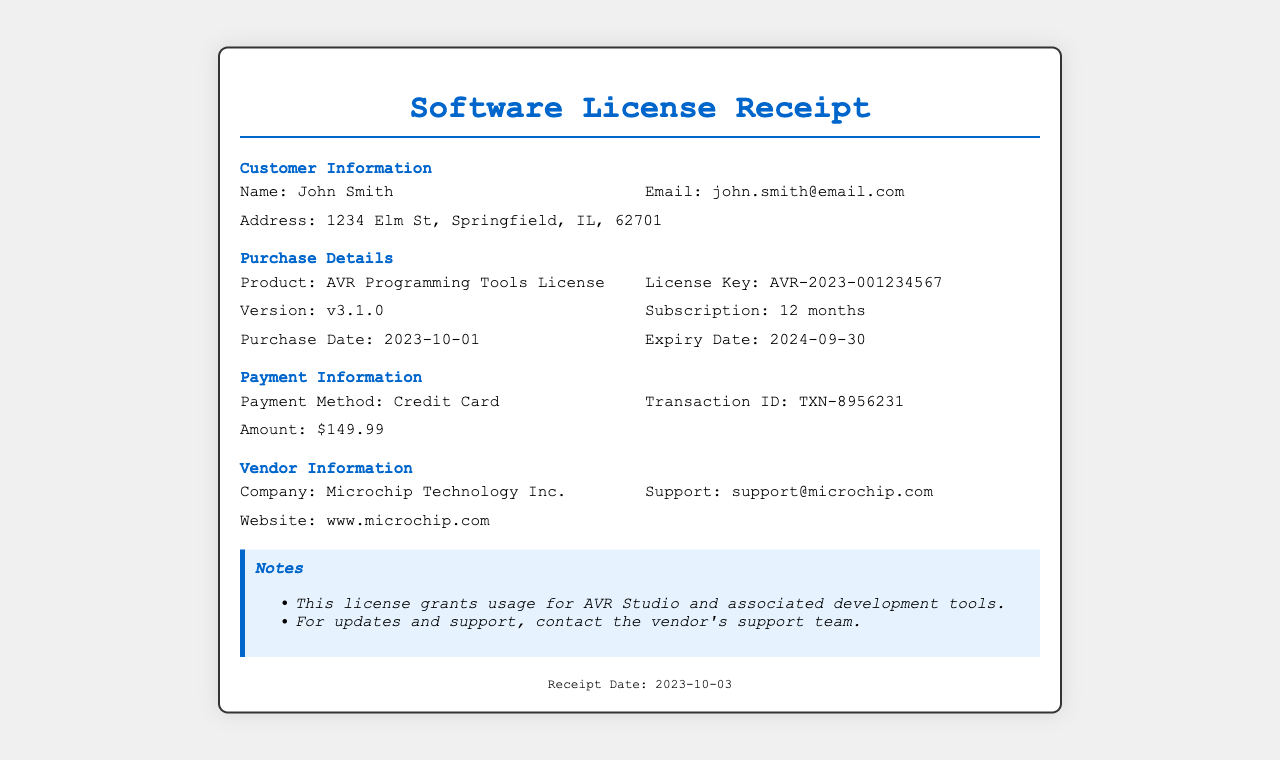What is the customer name? The customer's name is found in the customer information section of the document.
Answer: John Smith What is the purchase date? The purchase date is mentioned in the purchase details section of the document.
Answer: 2023-10-01 What is the expiry date of the subscription? The expiry date is listed alongside the subscription duration in the purchase details section.
Answer: 2024-09-30 What is the version of the AVR Programming Tools License? The version detail is provided in the purchase details section of the document.
Answer: v3.1.0 How long is the subscription valid for? The duration of the subscription can be found in the purchase details section.
Answer: 12 months What is the transaction ID? The transaction ID can be found in the payment information section of the document.
Answer: TXN-8956231 What was the amount paid for the license? The amount paid is specified in the payment information section of the receipt.
Answer: $149.99 Which company sold the license? The vendor company name is mentioned in the vendor information section of the document.
Answer: Microchip Technology Inc What type of receipt is this? The title of the document indicates the type of receipt it is.
Answer: Software License Receipt 